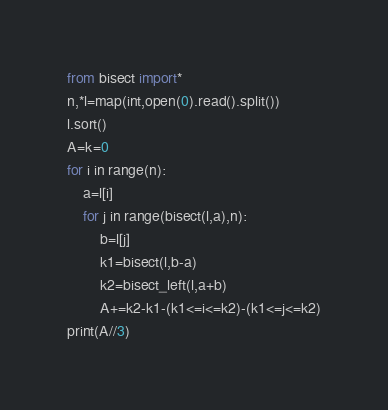<code> <loc_0><loc_0><loc_500><loc_500><_Python_>from bisect import*
n,*l=map(int,open(0).read().split())
l.sort()
A=k=0
for i in range(n):
    a=l[i]
    for j in range(bisect(l,a),n):
        b=l[j]
        k1=bisect(l,b-a)
        k2=bisect_left(l,a+b)
        A+=k2-k1-(k1<=i<=k2)-(k1<=j<=k2)
print(A//3)</code> 